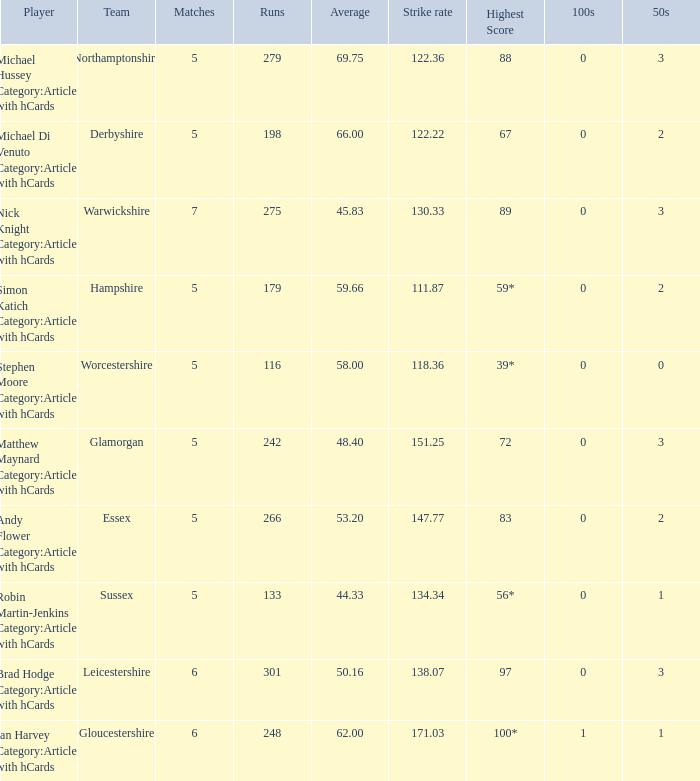Would you mind parsing the complete table? {'header': ['Player', 'Team', 'Matches', 'Runs', 'Average', 'Strike rate', 'Highest Score', '100s', '50s'], 'rows': [['Michael Hussey Category:Articles with hCards', 'Northamptonshire', '5', '279', '69.75', '122.36', '88', '0', '3'], ['Michael Di Venuto Category:Articles with hCards', 'Derbyshire', '5', '198', '66.00', '122.22', '67', '0', '2'], ['Nick Knight Category:Articles with hCards', 'Warwickshire', '7', '275', '45.83', '130.33', '89', '0', '3'], ['Simon Katich Category:Articles with hCards', 'Hampshire', '5', '179', '59.66', '111.87', '59*', '0', '2'], ['Stephen Moore Category:Articles with hCards', 'Worcestershire', '5', '116', '58.00', '118.36', '39*', '0', '0'], ['Matthew Maynard Category:Articles with hCards', 'Glamorgan', '5', '242', '48.40', '151.25', '72', '0', '3'], ['Andy Flower Category:Articles with hCards', 'Essex', '5', '266', '53.20', '147.77', '83', '0', '2'], ['Robin Martin-Jenkins Category:Articles with hCards', 'Sussex', '5', '133', '44.33', '134.34', '56*', '0', '1'], ['Brad Hodge Category:Articles with hCards', 'Leicestershire', '6', '301', '50.16', '138.07', '97', '0', '3'], ['Ian Harvey Category:Articles with hCards', 'Gloucestershire', '6', '248', '62.00', '171.03', '100*', '1', '1']]} What is the team Sussex' highest score? 56*. 